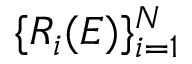Convert formula to latex. <formula><loc_0><loc_0><loc_500><loc_500>\{ R _ { i } ( E ) \} _ { i = 1 } ^ { N }</formula> 